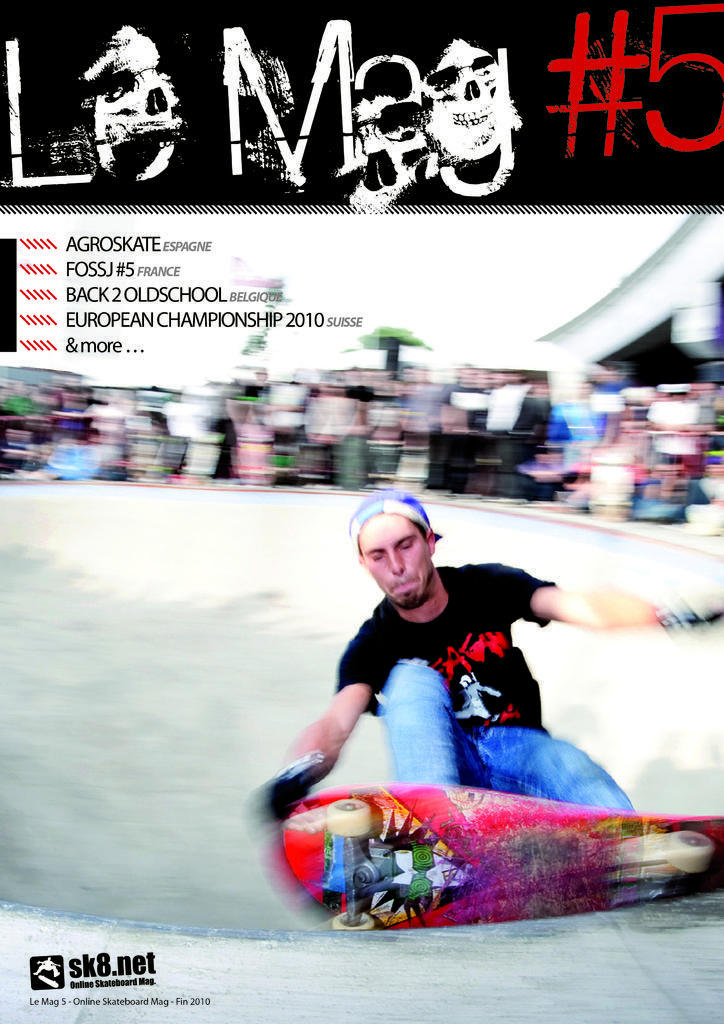Please provide a concise description of this image. In this image there is one person doing skating as we can see in middle of this image and there are some objects in the background. There is some text and there is a logo on the top of this image. 